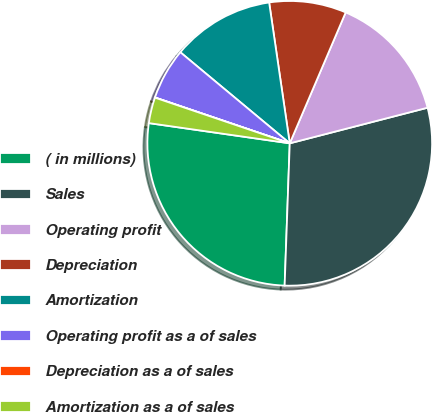<chart> <loc_0><loc_0><loc_500><loc_500><pie_chart><fcel>( in millions)<fcel>Sales<fcel>Operating profit<fcel>Depreciation<fcel>Amortization<fcel>Operating profit as a of sales<fcel>Depreciation as a of sales<fcel>Amortization as a of sales<nl><fcel>26.7%<fcel>29.6%<fcel>14.55%<fcel>8.74%<fcel>11.64%<fcel>5.83%<fcel>0.02%<fcel>2.93%<nl></chart> 